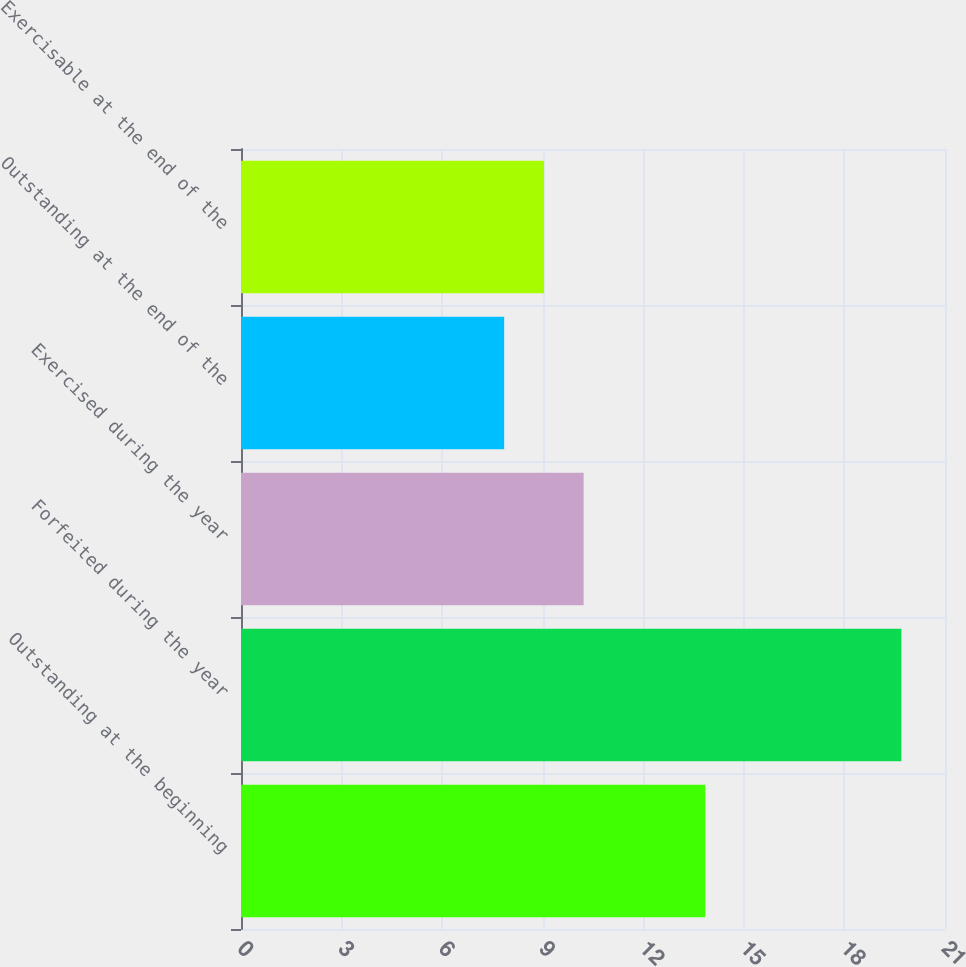Convert chart. <chart><loc_0><loc_0><loc_500><loc_500><bar_chart><fcel>Outstanding at the beginning<fcel>Forfeited during the year<fcel>Exercised during the year<fcel>Outstanding at the end of the<fcel>Exercisable at the end of the<nl><fcel>13.85<fcel>19.7<fcel>10.22<fcel>7.85<fcel>9.04<nl></chart> 